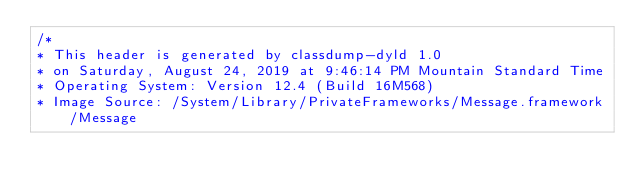<code> <loc_0><loc_0><loc_500><loc_500><_C_>/*
* This header is generated by classdump-dyld 1.0
* on Saturday, August 24, 2019 at 9:46:14 PM Mountain Standard Time
* Operating System: Version 12.4 (Build 16M568)
* Image Source: /System/Library/PrivateFrameworks/Message.framework/Message</code> 